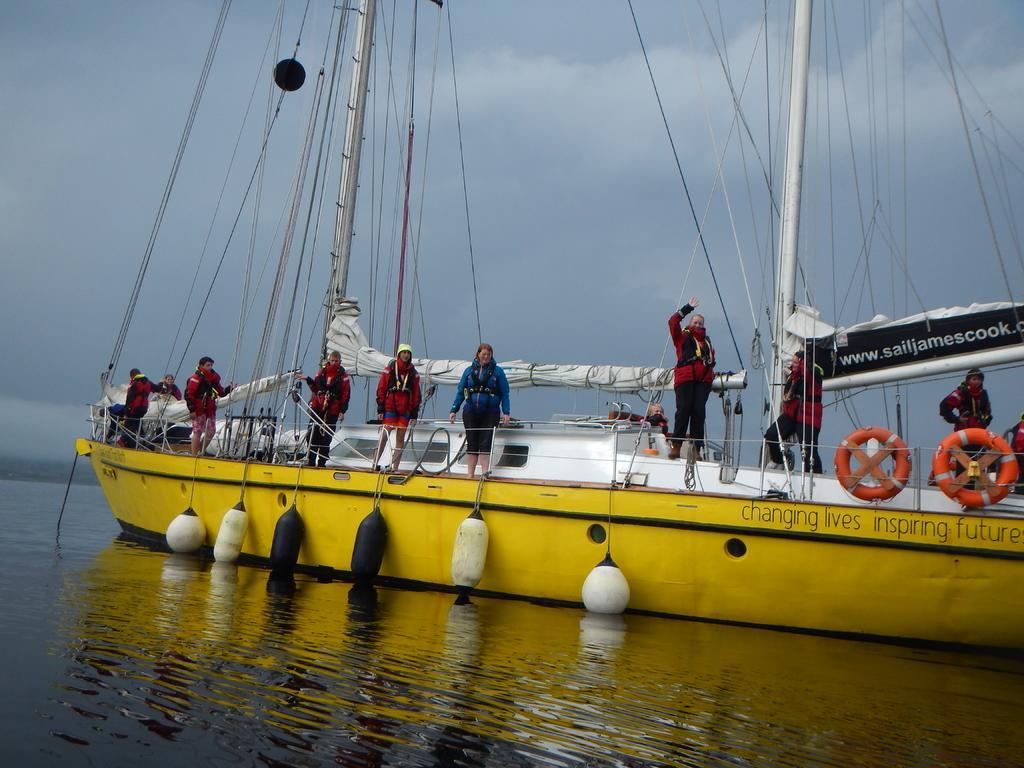Can you describe this image briefly? In this image there is a boat sailing on the surface of the water. There are bags hanging from the boat. There are people standing on the boat. Top of the image there is sky. 